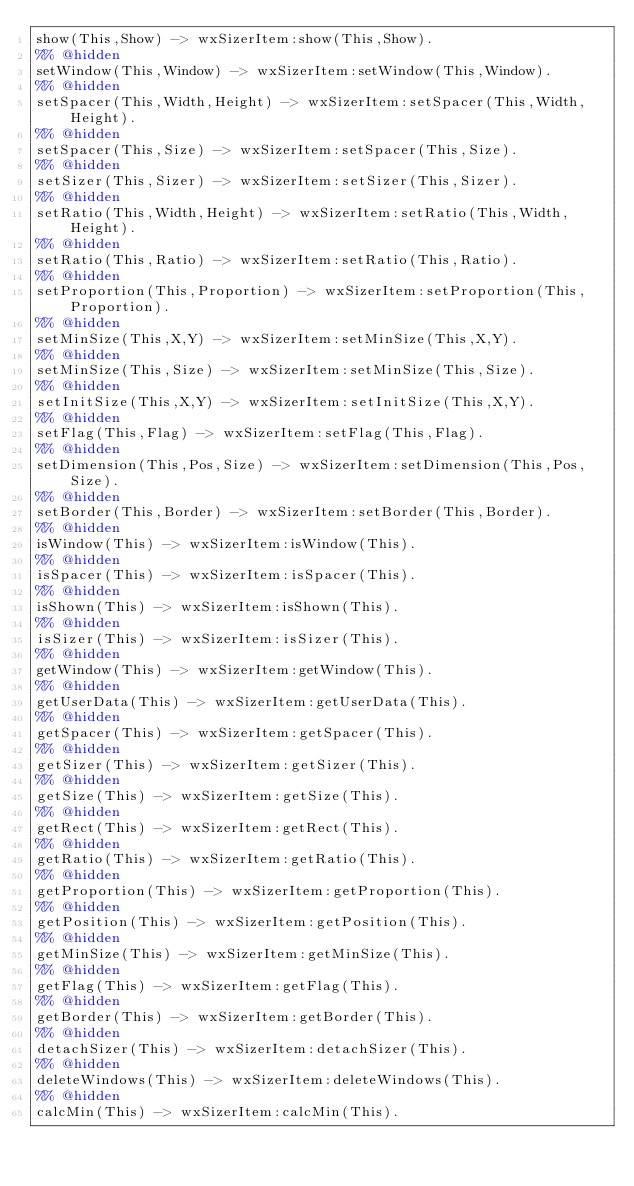Convert code to text. <code><loc_0><loc_0><loc_500><loc_500><_Erlang_>show(This,Show) -> wxSizerItem:show(This,Show).
%% @hidden
setWindow(This,Window) -> wxSizerItem:setWindow(This,Window).
%% @hidden
setSpacer(This,Width,Height) -> wxSizerItem:setSpacer(This,Width,Height).
%% @hidden
setSpacer(This,Size) -> wxSizerItem:setSpacer(This,Size).
%% @hidden
setSizer(This,Sizer) -> wxSizerItem:setSizer(This,Sizer).
%% @hidden
setRatio(This,Width,Height) -> wxSizerItem:setRatio(This,Width,Height).
%% @hidden
setRatio(This,Ratio) -> wxSizerItem:setRatio(This,Ratio).
%% @hidden
setProportion(This,Proportion) -> wxSizerItem:setProportion(This,Proportion).
%% @hidden
setMinSize(This,X,Y) -> wxSizerItem:setMinSize(This,X,Y).
%% @hidden
setMinSize(This,Size) -> wxSizerItem:setMinSize(This,Size).
%% @hidden
setInitSize(This,X,Y) -> wxSizerItem:setInitSize(This,X,Y).
%% @hidden
setFlag(This,Flag) -> wxSizerItem:setFlag(This,Flag).
%% @hidden
setDimension(This,Pos,Size) -> wxSizerItem:setDimension(This,Pos,Size).
%% @hidden
setBorder(This,Border) -> wxSizerItem:setBorder(This,Border).
%% @hidden
isWindow(This) -> wxSizerItem:isWindow(This).
%% @hidden
isSpacer(This) -> wxSizerItem:isSpacer(This).
%% @hidden
isShown(This) -> wxSizerItem:isShown(This).
%% @hidden
isSizer(This) -> wxSizerItem:isSizer(This).
%% @hidden
getWindow(This) -> wxSizerItem:getWindow(This).
%% @hidden
getUserData(This) -> wxSizerItem:getUserData(This).
%% @hidden
getSpacer(This) -> wxSizerItem:getSpacer(This).
%% @hidden
getSizer(This) -> wxSizerItem:getSizer(This).
%% @hidden
getSize(This) -> wxSizerItem:getSize(This).
%% @hidden
getRect(This) -> wxSizerItem:getRect(This).
%% @hidden
getRatio(This) -> wxSizerItem:getRatio(This).
%% @hidden
getProportion(This) -> wxSizerItem:getProportion(This).
%% @hidden
getPosition(This) -> wxSizerItem:getPosition(This).
%% @hidden
getMinSize(This) -> wxSizerItem:getMinSize(This).
%% @hidden
getFlag(This) -> wxSizerItem:getFlag(This).
%% @hidden
getBorder(This) -> wxSizerItem:getBorder(This).
%% @hidden
detachSizer(This) -> wxSizerItem:detachSizer(This).
%% @hidden
deleteWindows(This) -> wxSizerItem:deleteWindows(This).
%% @hidden
calcMin(This) -> wxSizerItem:calcMin(This).
</code> 